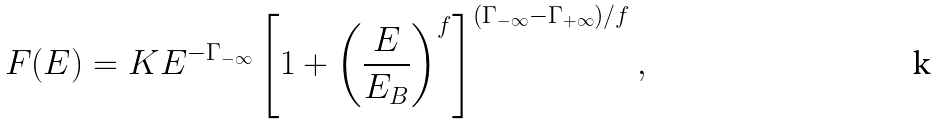<formula> <loc_0><loc_0><loc_500><loc_500>F ( E ) = K E ^ { - \Gamma _ { - \infty } } \left [ 1 + \left ( \frac { E } { E _ { B } } \right ) ^ { f } \right ] ^ { ( \Gamma _ { - \infty } - \Gamma _ { + \infty } ) / f } ,</formula> 